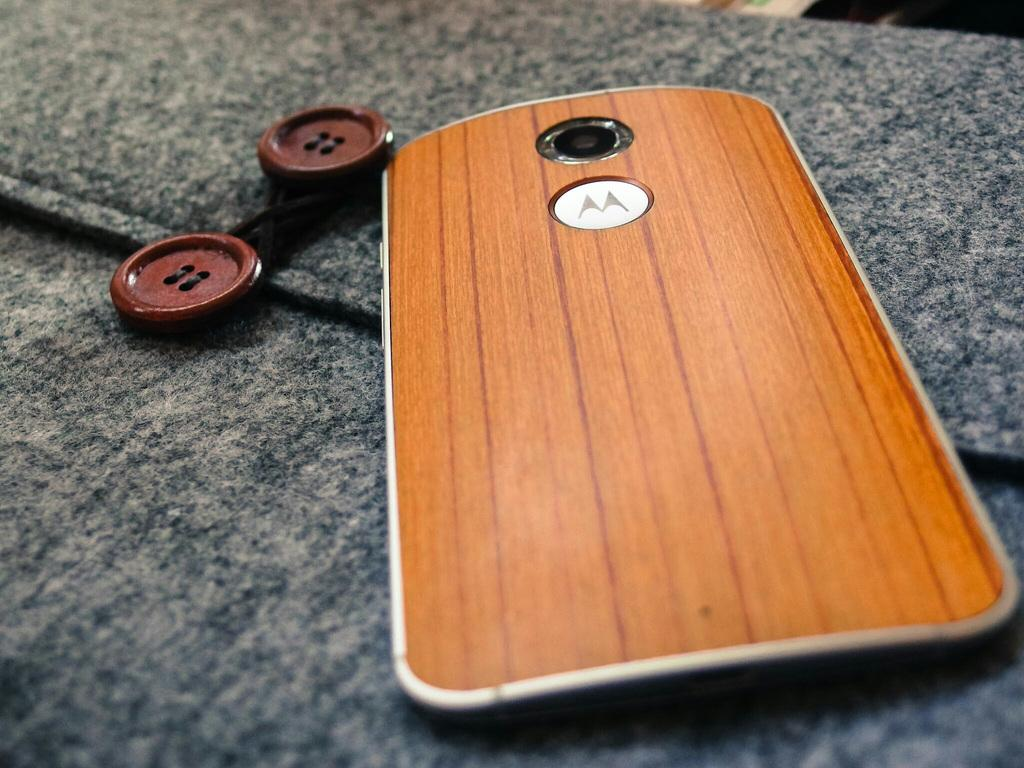<image>
Describe the image concisely. A phone with a wood looking case sits one fabric next to two buttons and has an M on the back of it. 